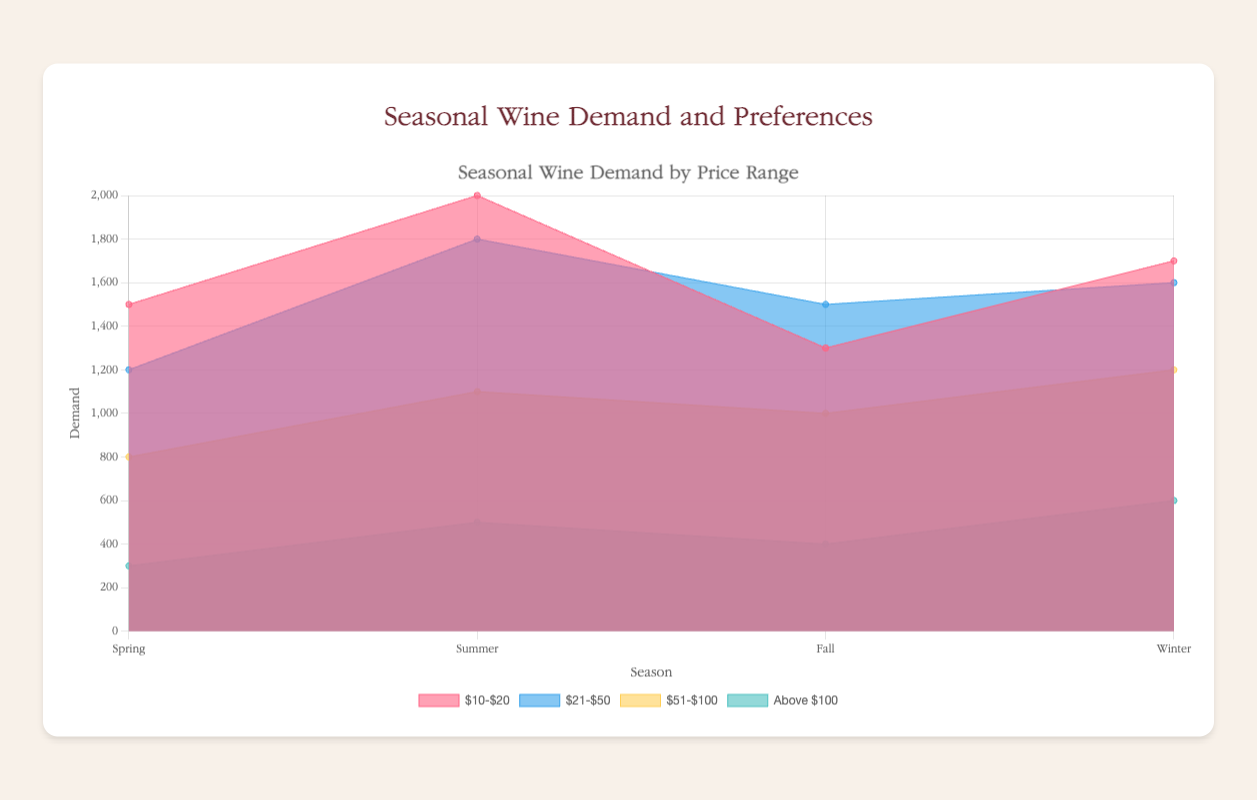What is the season with the highest demand for wines priced between $10-$20? In the figure, observe the segments corresponding to the price range $10-$20 and compare their heights across different seasons. The highest peak in this price range is during Summer.
Answer: Summer Which price range has the highest demand in Spring? Look at the segments in Spring and compare their heights across different price ranges. The tallest segment corresponds to the price range $10-$20.
Answer: $10-$20 How does the demand for wines priced above $100 change from Summer to Winter? Find the segments for the price range "Above $100" in both Summer and Winter. Compare their heights to determine the change. Demand increases from 500 in Summer to 600 in Winter.
Answer: It increases What is the combined demand for wines priced between $51-$100 in Summer and Fall? Identify the heights of the segments for the price range $51-$100 in Summer and Fall. The demand in Summer is 1100, and in Fall is 1000. Summing them up gives 1100 + 1000 = 2100.
Answer: 2100 Which season has the lowest demand for wines priced above $100? Compare the heights of the segments for the price range "Above $100" across all seasons. The shortest segment is in Spring.
Answer: Spring In which season is the demand for red wine the highest? For each season, find the segments corresponding to red wine and compare their heights. Winter has the highest segment for red wine with a demand of 1700.
Answer: Winter Does the demand for sparkling wine always increase or decrease with higher price ranges across seasons? Evaluate the demand for sparkling wine across different price ranges within each season. Check whether the demand consistently increases or decreases. In Spring, it decreases from 800 to 300, while in Winter, it increases from 1600 to 600.
Answer: It does not consistently increase or decrease What is the total demand for all price ranges in Fall? Sum the heights of all segments in Fall for each price range. The demands are 1300, 1500, 1000, and 400. Adding these gives 1300 + 1500 + 1000 + 400 = 4200.
Answer: 4200 Which season has the most diversified wine types? Identify the seasons and count how many different wine types are represented. Spring, Summer, and Winter each have three types, while Fall only has one.
Answer: Spring, Summer, Winter 